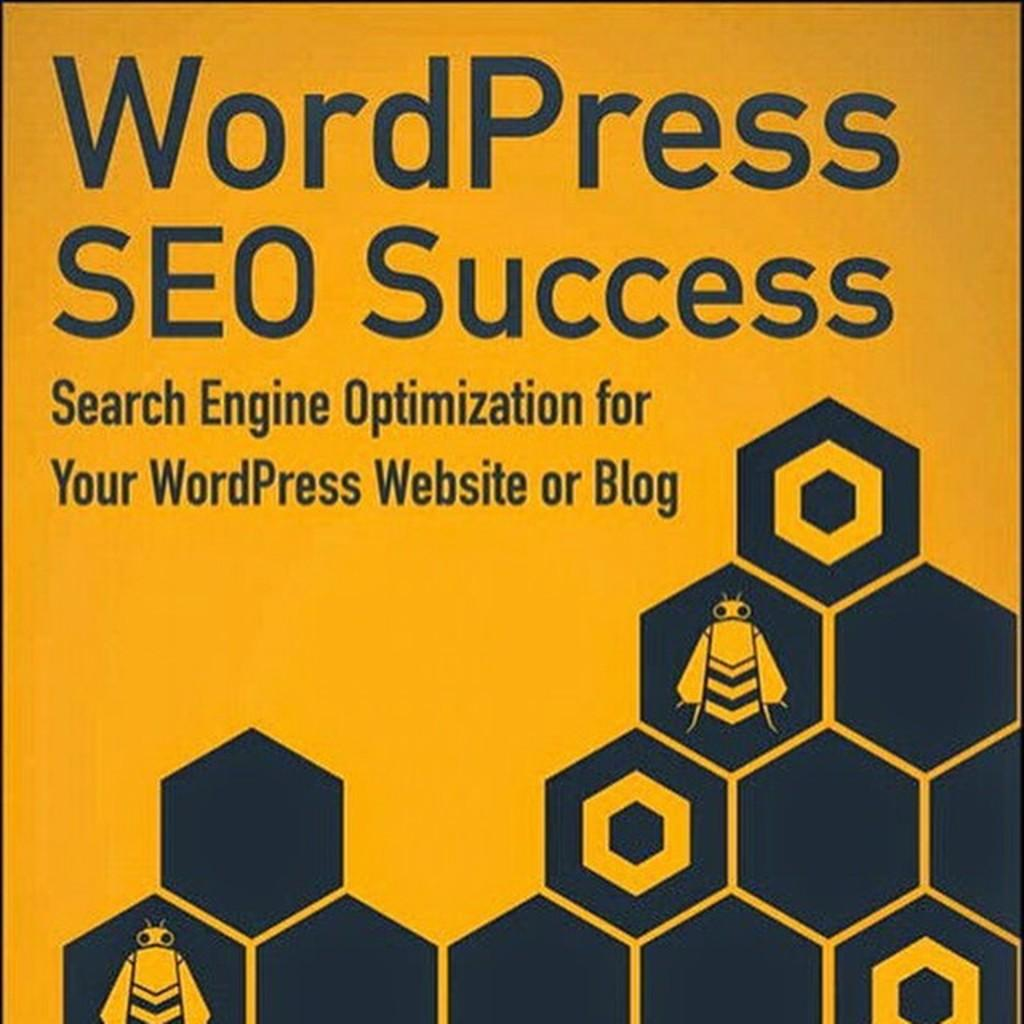What can be seen in the image? There are designs, a cartoon image of insects, and text in the image. Can you describe the cartoon image in the picture? The cartoon image in the picture features insects. What is written on the image? There is text written on the image. What type of learning can be observed at the party in the image? There is no party or learning activity present in the image; it features designs, a cartoon image of insects, and text. 